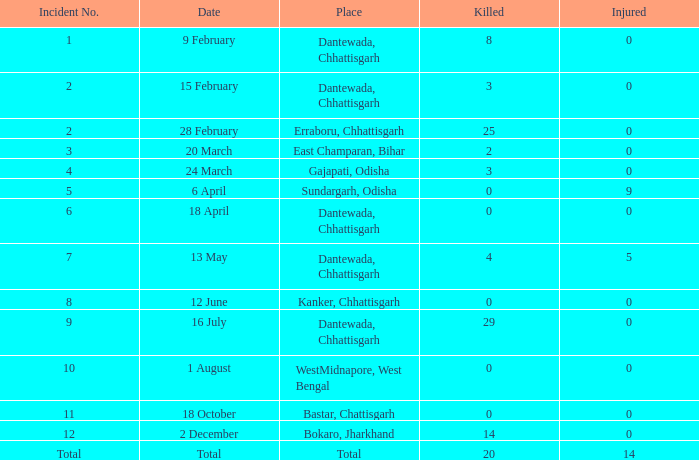What is the minimum number of injuries in dantewada, chhattisgarh when 8 individuals were killed? 0.0. 